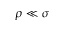Convert formula to latex. <formula><loc_0><loc_0><loc_500><loc_500>\rho \ll \sigma</formula> 